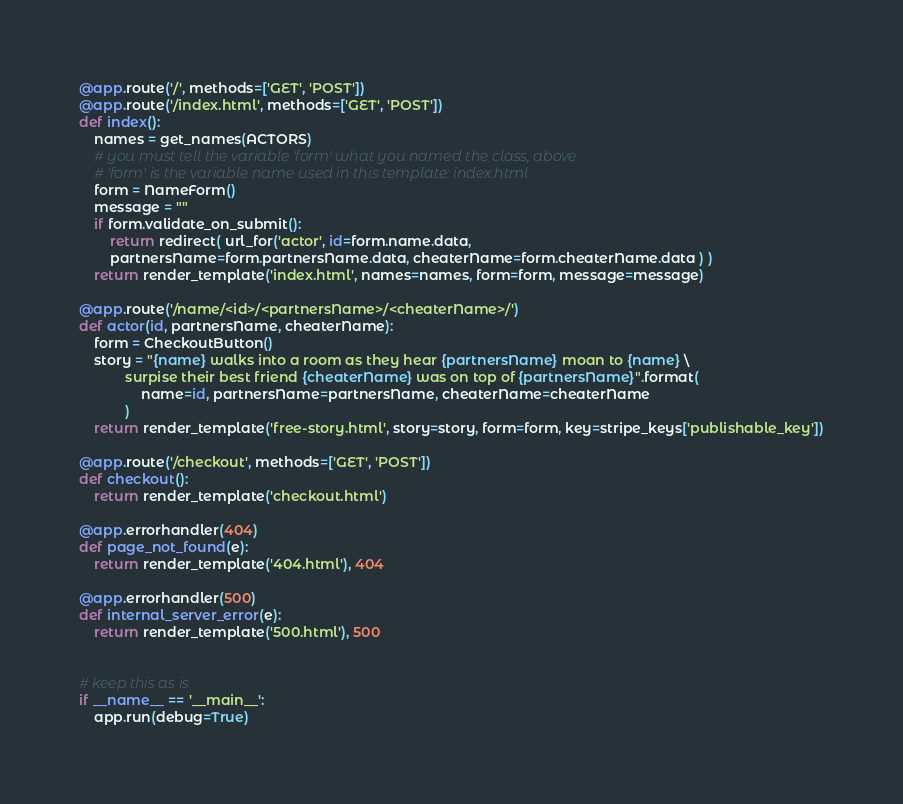<code> <loc_0><loc_0><loc_500><loc_500><_Python_>@app.route('/', methods=['GET', 'POST'])
@app.route('/index.html', methods=['GET', 'POST'])
def index():
    names = get_names(ACTORS)
    # you must tell the variable 'form' what you named the class, above
    # 'form' is the variable name used in this template: index.html
    form = NameForm()
    message = ""
    if form.validate_on_submit():
        return redirect( url_for('actor', id=form.name.data,
        partnersName=form.partnersName.data, cheaterName=form.cheaterName.data ) )
    return render_template('index.html', names=names, form=form, message=message)

@app.route('/name/<id>/<partnersName>/<cheaterName>/')
def actor(id, partnersName, cheaterName):
    form = CheckoutButton()
    story = "{name} walks into a room as they hear {partnersName} moan to {name} \
            surpise their best friend {cheaterName} was on top of {partnersName}".format(
                name=id, partnersName=partnersName, cheaterName=cheaterName
            )
    return render_template('free-story.html', story=story, form=form, key=stripe_keys['publishable_key'])

@app.route('/checkout', methods=['GET', 'POST'])
def checkout():
    return render_template('checkout.html')

@app.errorhandler(404)
def page_not_found(e):
    return render_template('404.html'), 404

@app.errorhandler(500)
def internal_server_error(e):
    return render_template('500.html'), 500


# keep this as is
if __name__ == '__main__':
    app.run(debug=True)
</code> 